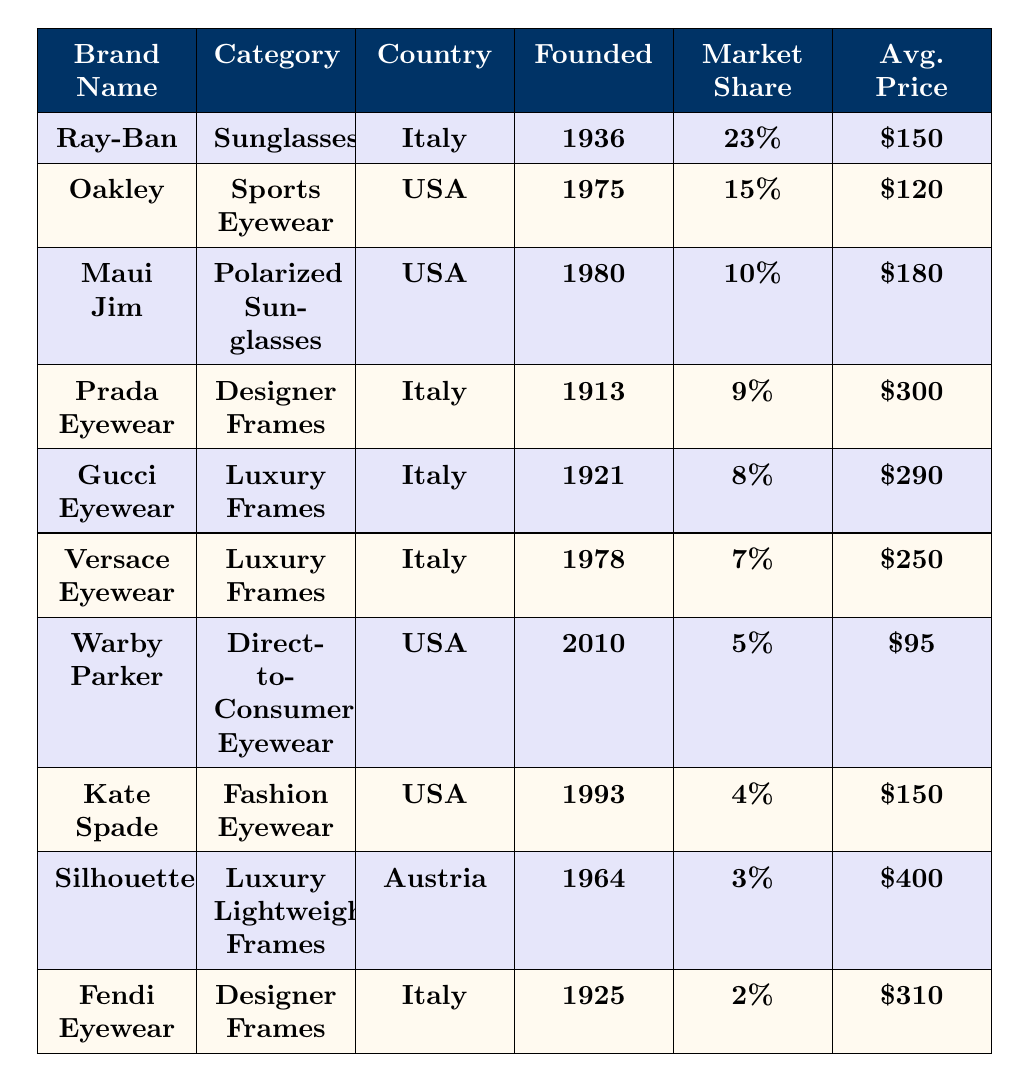What is the brand with the highest market share? The table shows that Ray-Ban has the highest market share at 23%.
Answer: Ray-Ban Which brand is the oldest in the list? By looking at the founded year for each brand, Prada Eyewear founded in 1913 is the oldest.
Answer: Prada Eyewear What is the average price of the top three brands? The average price is calculated as follows: (150 + 120 + 180) / 3 = 150.
Answer: 150 Is Oakley a designer frame brand? According to the table, Oakley is categorized as Sports Eyewear, not a designer.
Answer: No Which brand has the lowest average price? The average price table shows Warby Parker has the lowest price at $95.
Answer: Warby Parker What is the total market share of the top five brands combined? Adding the market shares gives: 23% + 15% + 10% + 9% + 8% = 65%.
Answer: 65% Which country has the most brands listed? Italy has four brands listed: Ray-Ban, Prada Eyewear, Gucci Eyewear, and Fendi Eyewear.
Answer: Italy How many brands have an average price over $200? From the table, the brands with prices over $200 are Prada Eyewear, Gucci Eyewear, Versace Eyewear, Silhouette, and Fendi Eyewear, which totals five.
Answer: Five What is the average market share percentage of all brands? The total market share is 100% and there are 10 brands, so the average is 100% / 10 = 10%.
Answer: 10% Which brand offers polarized sunglasses? The table indicates that Maui Jim is the brand that offers polarized sunglasses.
Answer: Maui Jim 